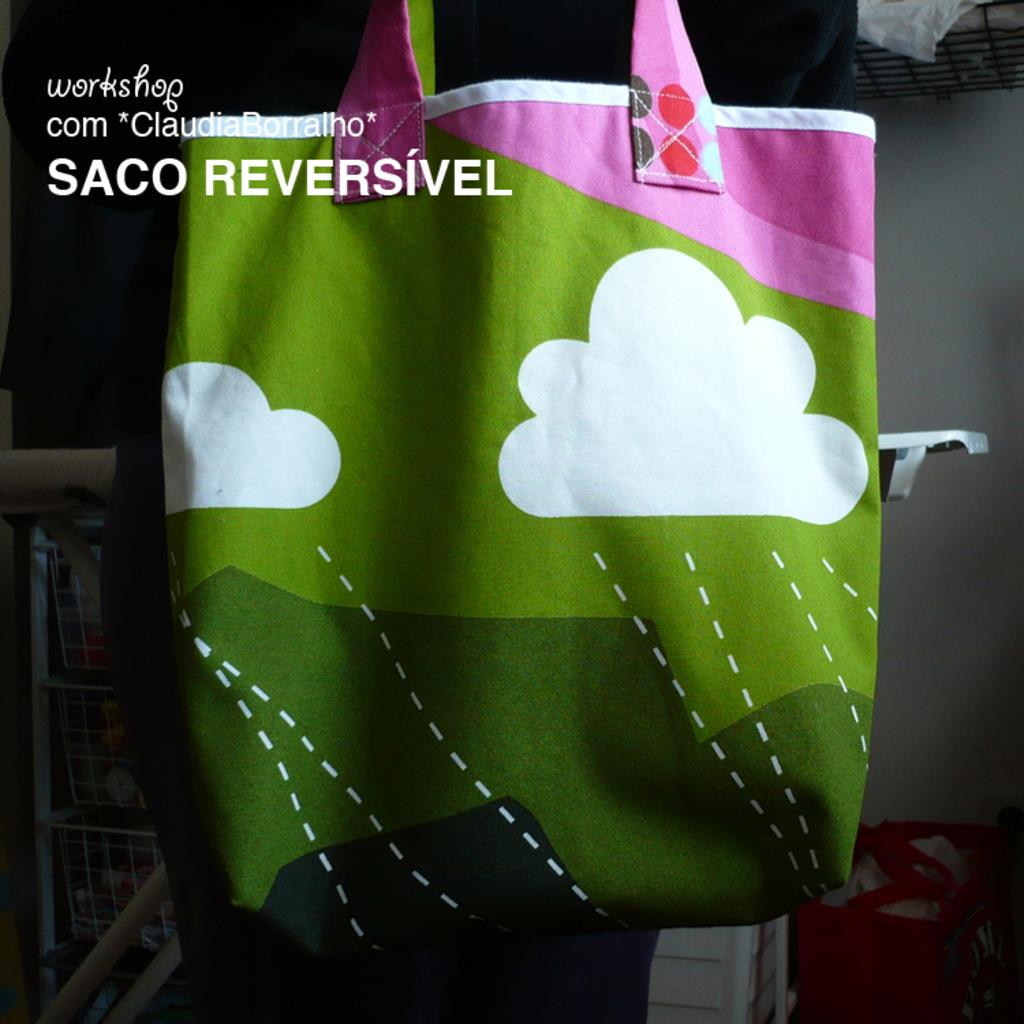What object is present in the image? There is a bag in the image. What design is featured on the bag? The bag has clouds designed on it. What colors can be seen on the bag? The bag is of three colors: white, red, and pink. How many sons are visible in the image? There are no sons present in the image; it features a bag with a cloud design. What type of hen can be seen in the image? There is no hen present in the image; it features a bag with a cloud design. 